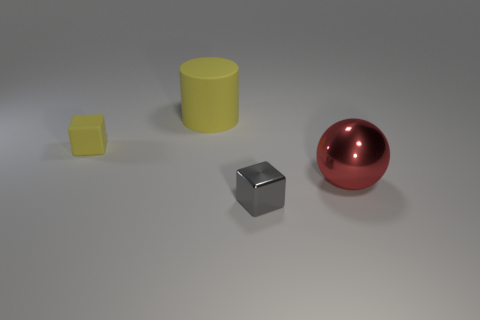Is there any other thing that has the same shape as the large red thing?
Provide a succinct answer. No. Do the cylinder and the big shiny ball have the same color?
Your answer should be very brief. No. What is the color of the big object right of the small cube that is on the right side of the large object that is on the left side of the metal ball?
Your answer should be very brief. Red. How many tiny yellow things are in front of the yellow rubber cylinder left of the metallic object that is in front of the large metal sphere?
Offer a terse response. 1. Is there anything else of the same color as the tiny rubber object?
Make the answer very short. Yes. Do the yellow cylinder to the left of the red shiny object and the small gray metallic block have the same size?
Your answer should be very brief. No. There is a thing that is on the left side of the large yellow object; how many objects are to the right of it?
Your answer should be very brief. 3. Are there any yellow blocks behind the rubber thing that is right of the small block that is on the left side of the small metal object?
Keep it short and to the point. No. There is another small object that is the same shape as the small gray thing; what is it made of?
Provide a short and direct response. Rubber. Is there anything else that is made of the same material as the yellow block?
Make the answer very short. Yes. 